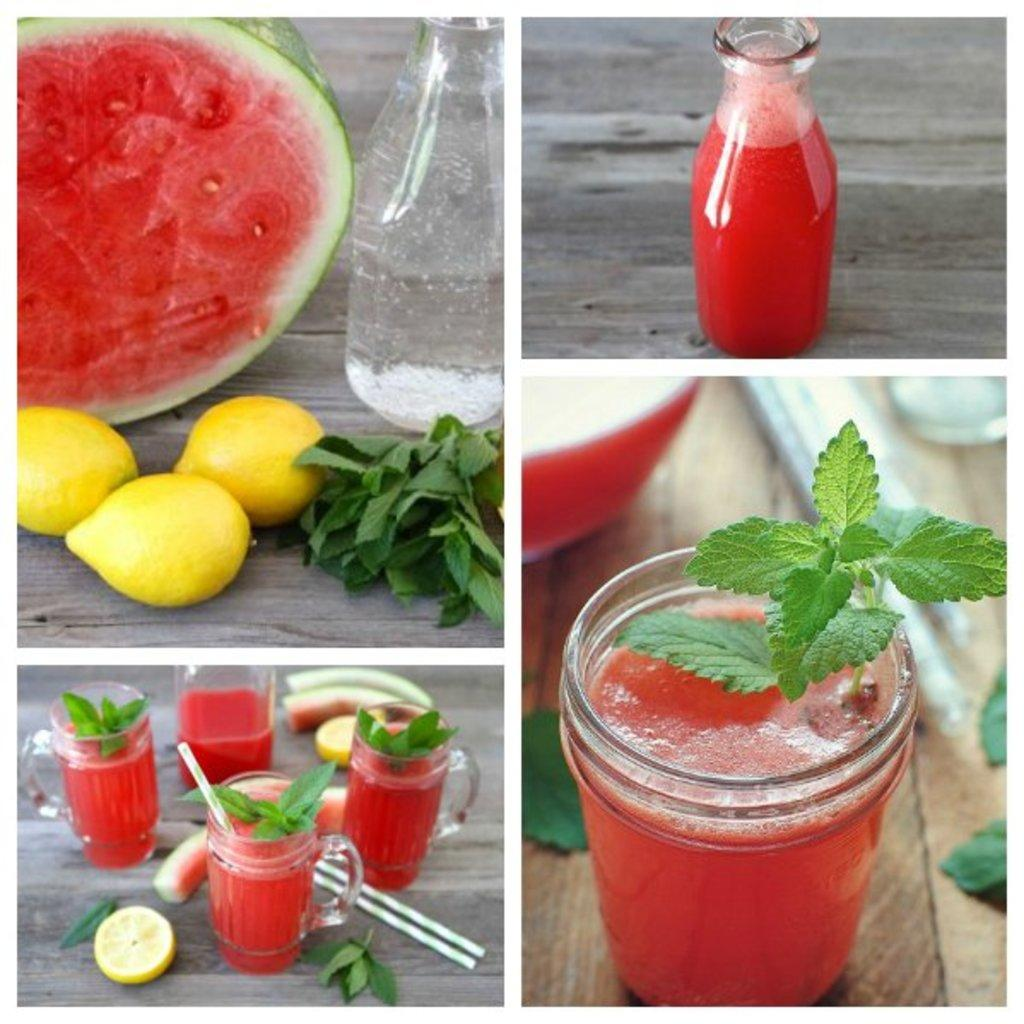What type of fruit is present in the photo collage? There is a watermelon and lemons in the photo collage. What other objects can be seen in the photo collage? There is a glass in the photo collage. How many trucks are parked at the airport in the photo collage? There are no trucks or airport present in the photo collage; it only features a watermelon, lemons, and a glass. 